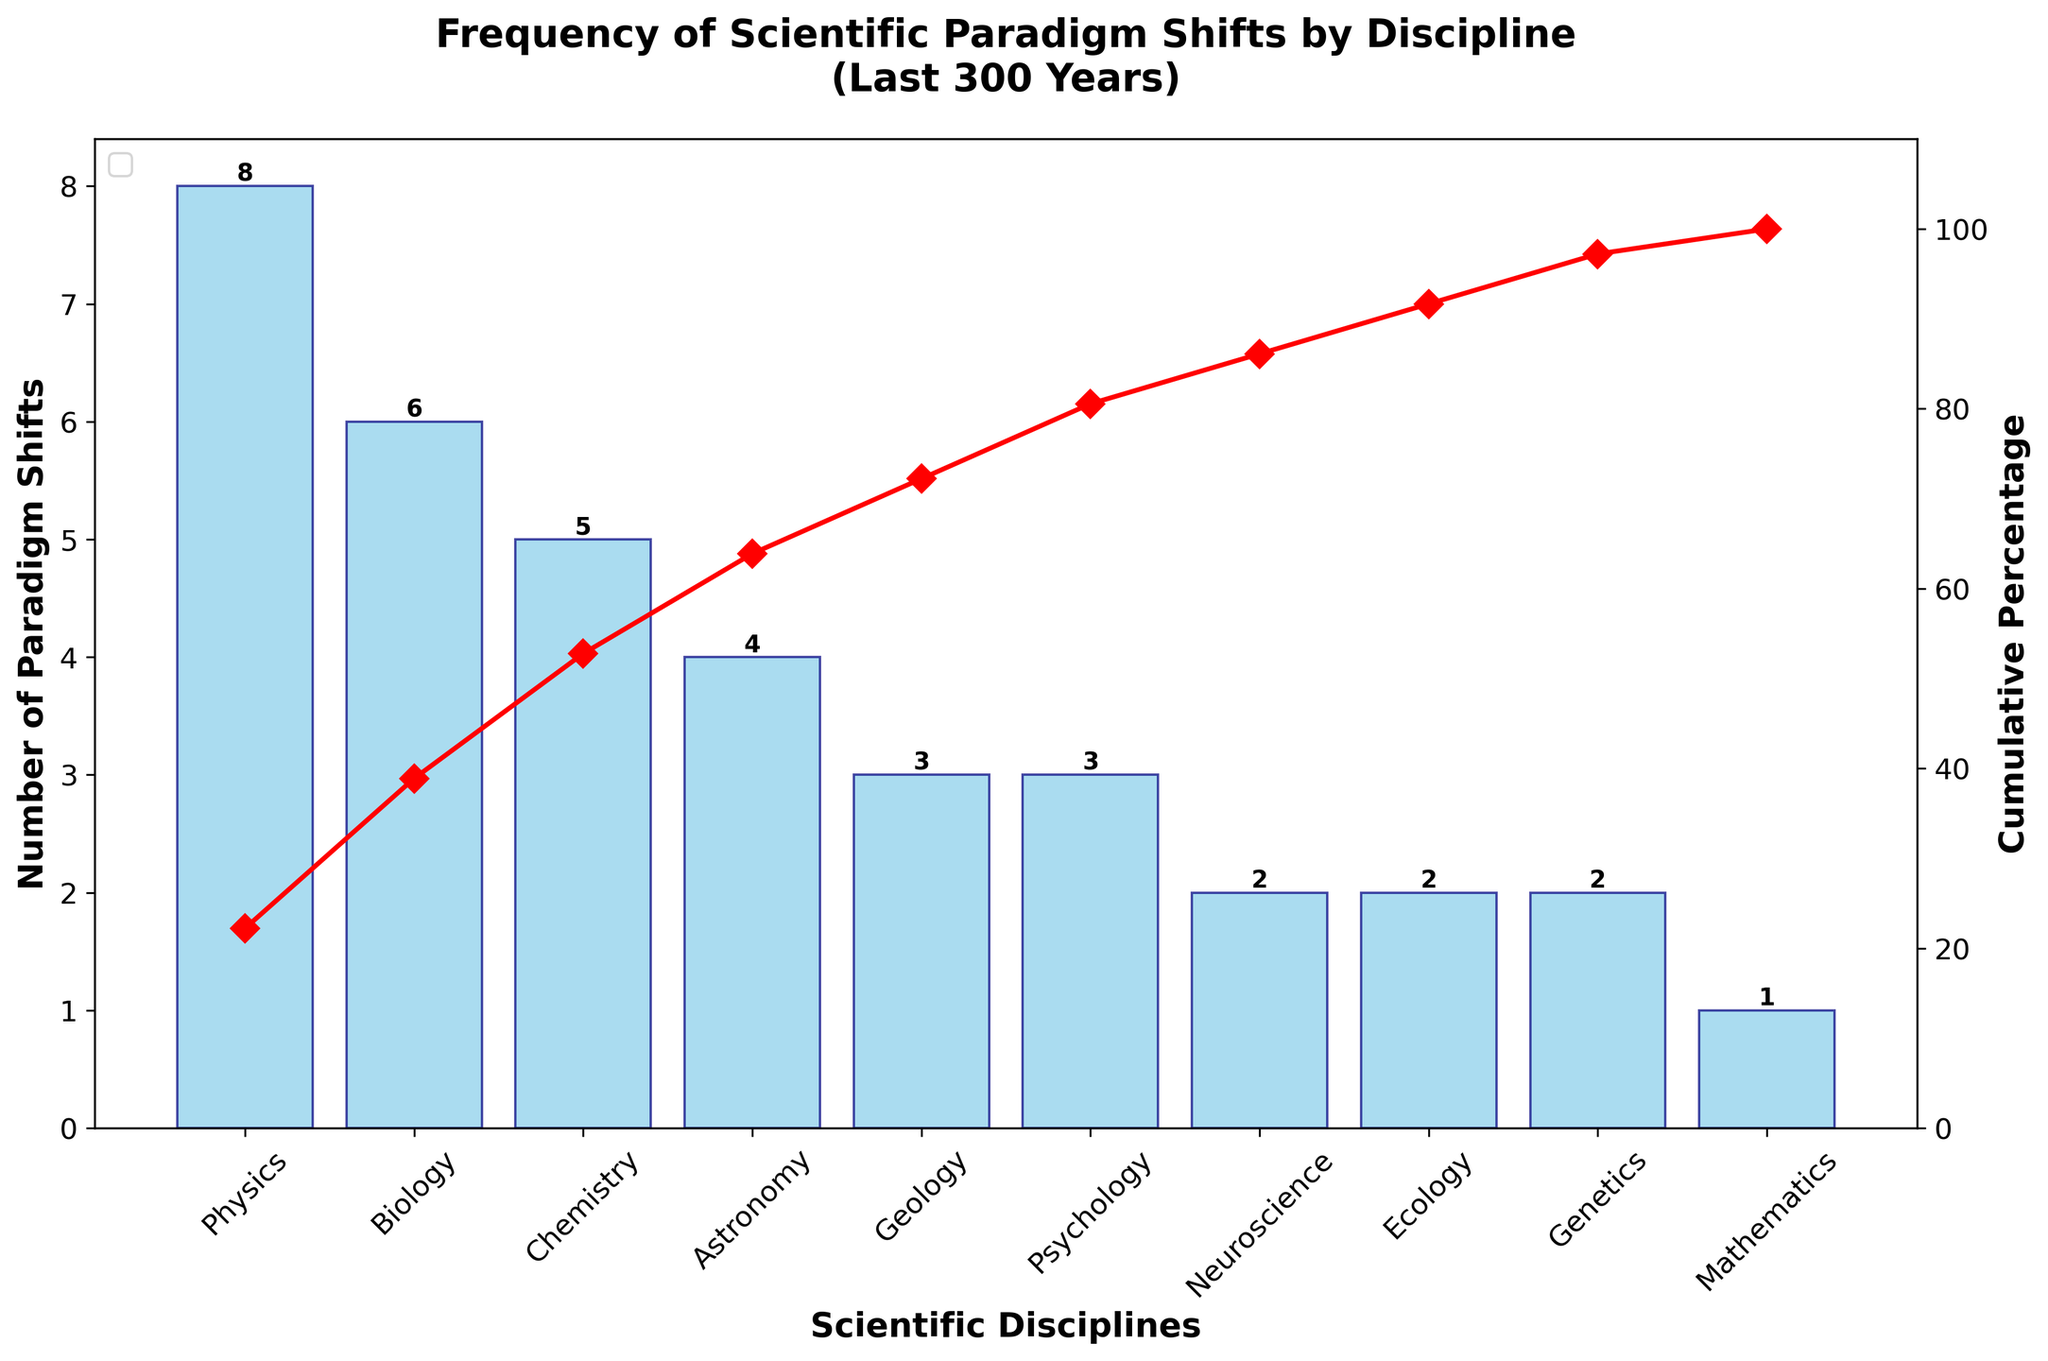what is the title of the figure? The title is usually placed at the top of the figure. It provides a brief description of what the figure is about. By looking at the top of the figure, we can read the complete title.
Answer: Frequency of Scientific Paradigm Shifts by Discipline (Last 300 Years) How many paradigm shifts occurred in Physics? We look for the bar representing Physics and find its height. The label at the top of this bar indicates the number of paradigm shifts.
Answer: 8 Which discipline has the lowest number of paradigm shifts? By looking at the bar chart, the shortest bar will show the discipline with the lowest number of shifts. We then read the label associated with this shortest bar.
Answer: Mathematics What is the cumulative percentage of paradigm shifts by the time we reach Chemistry? To find this, we locate the cumulative percentage line and see where it intersects above Chemistry's label.
Answer: 65% Which discipline has a cumulative percentage closest to 80%? We trace the cumulative percentage line to find the point closest to 80%, and then check the corresponding discipline below this point.
Answer: Geology How many more paradigm shifts are there in Physics compared to Neuroscience? First, we find the number of paradigm shifts in Physics and Neuroscience. Subtract Neuroscience's value from Physics's value. (8 - 2)
Answer: 6 What percentage of total paradigm shifts does Biology represent? To calculate the percentage, divide the number of paradigm shifts in Biology by the total number of paradigm shifts, then multiply by 100. (6/36 * 100)
Answer: 16.67% Which two disciplines have the same number of paradigm shifts? By scanning the bar heights and their labels, we find the bars with the same numerical labels.
Answer: Psychology and Geology What is the sum of paradigm shifts in Ecology, Genetics, and Mathematics? We look up the values for each of these disciplines and add them together: 2 (Ecology) + 2 (Genetics) + 1 (Mathematics)
Answer: 5 Which discipline ranks fourth in terms of the number of paradigm shifts? We identify the fourth tallest bar from left to right and read the corresponding discipline's label.
Answer: Astronomy 